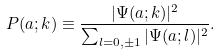Convert formula to latex. <formula><loc_0><loc_0><loc_500><loc_500>P ( a ; k ) \equiv \frac { | \Psi ( a ; k ) | ^ { 2 } } { \sum _ { l = 0 , \pm 1 } | \Psi ( a ; l ) | ^ { 2 } } .</formula> 